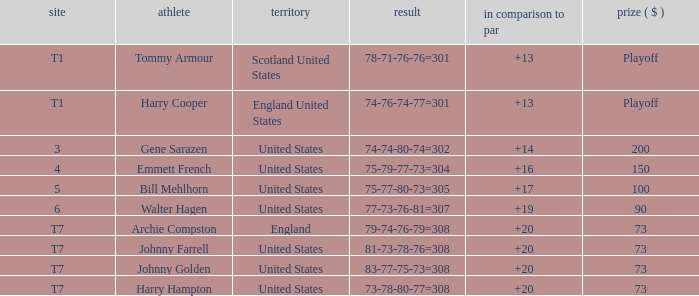What is the ranking for the United States when the money is $200? 3.0. 